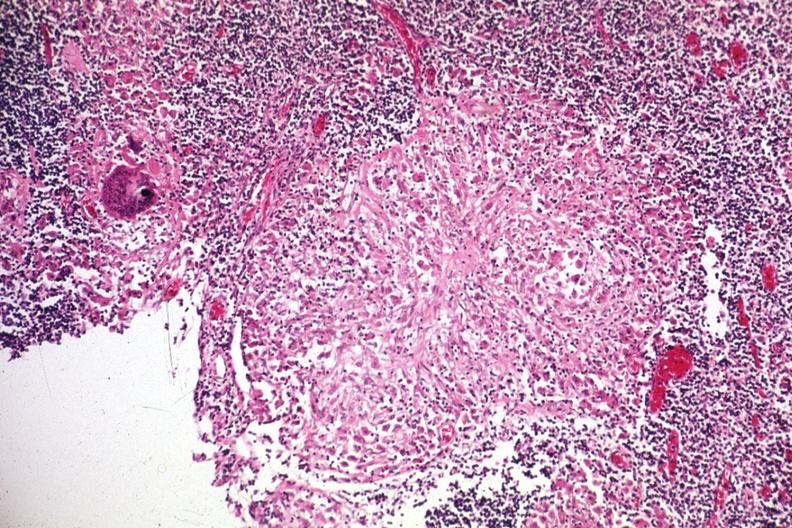what is present?
Answer the question using a single word or phrase. Sarcoidosis 